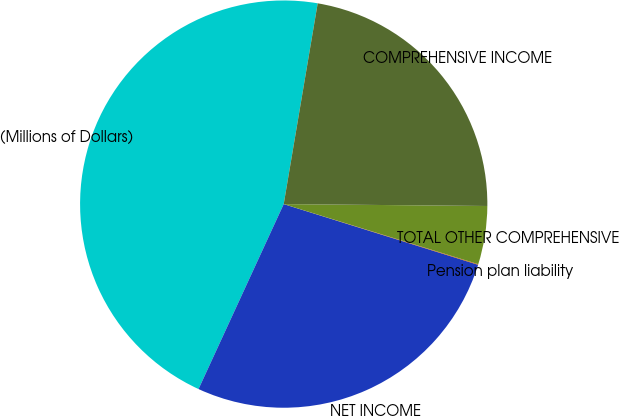Convert chart to OTSL. <chart><loc_0><loc_0><loc_500><loc_500><pie_chart><fcel>(Millions of Dollars)<fcel>NET INCOME<fcel>Pension plan liability<fcel>TOTAL OTHER COMPREHENSIVE<fcel>COMPREHENSIVE INCOME<nl><fcel>45.8%<fcel>27.05%<fcel>0.05%<fcel>4.62%<fcel>22.48%<nl></chart> 